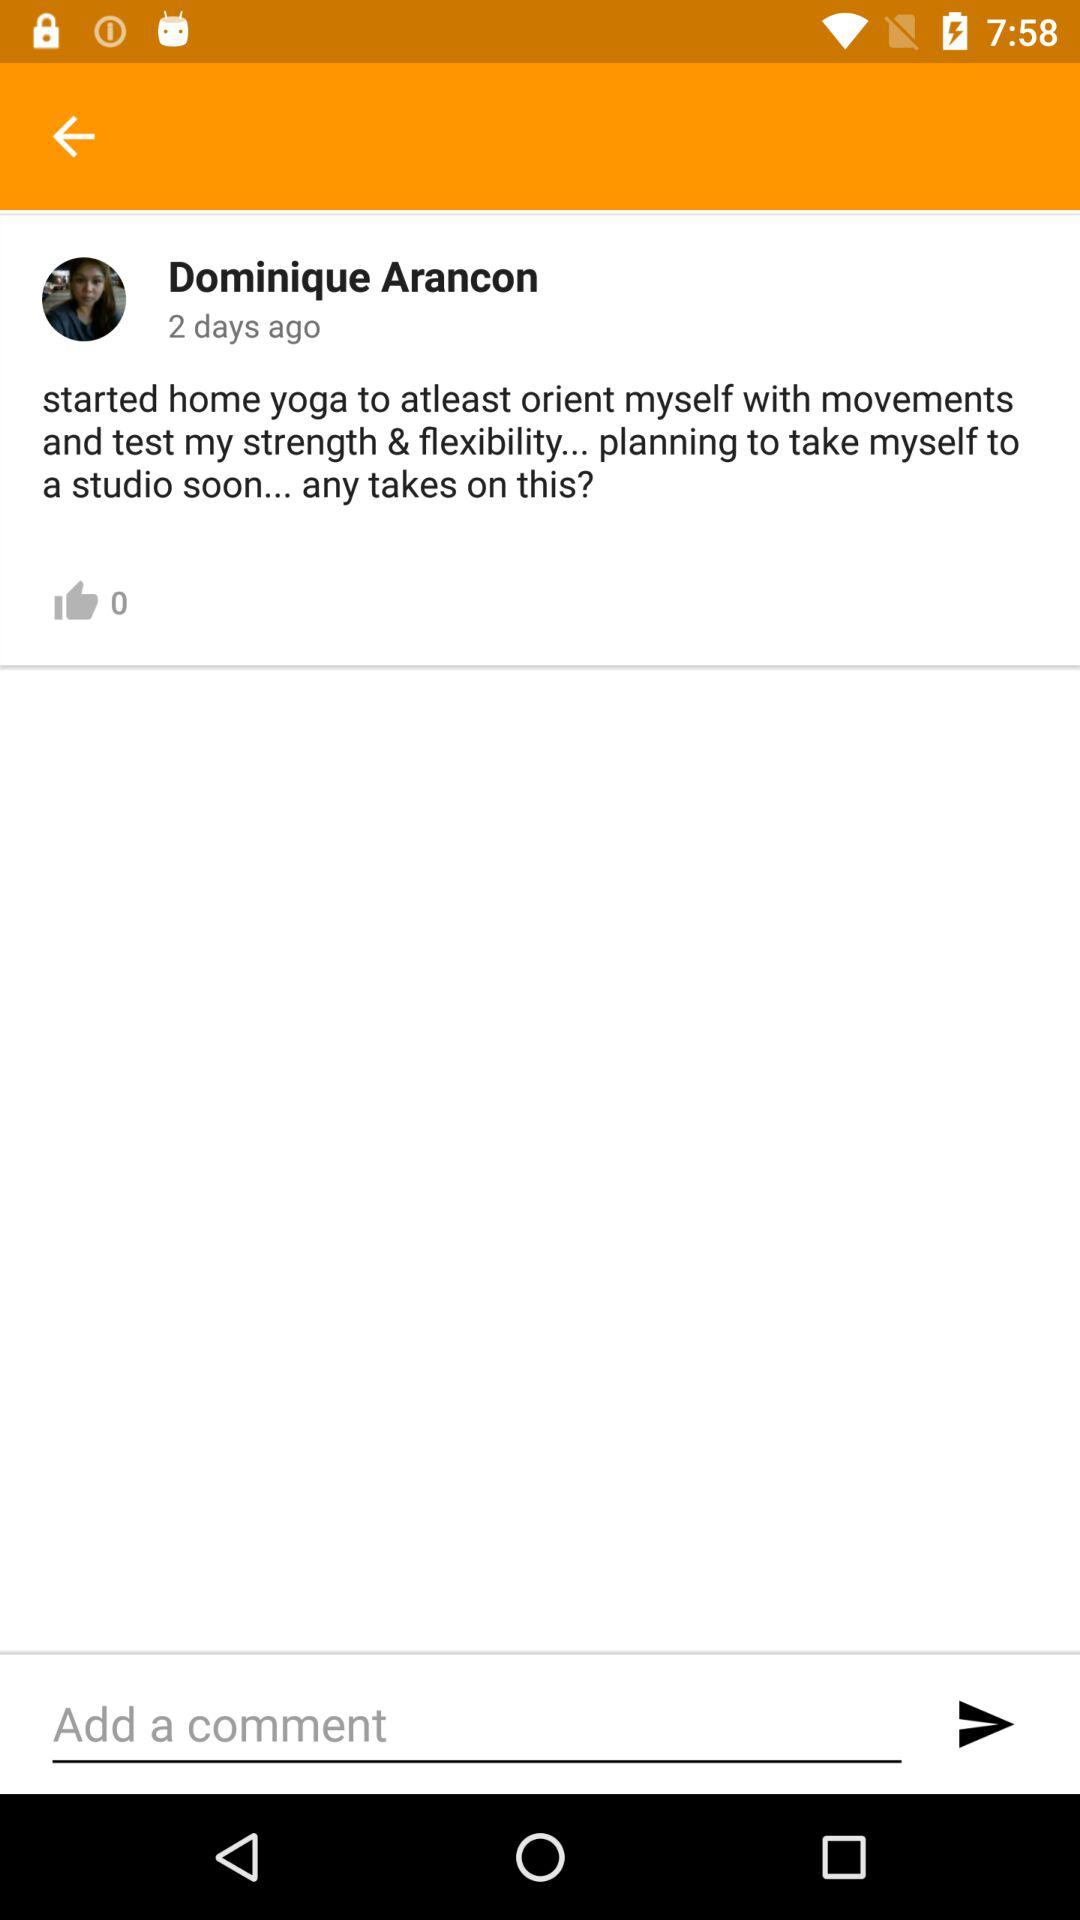How many likes are there? There are 0 likes. 